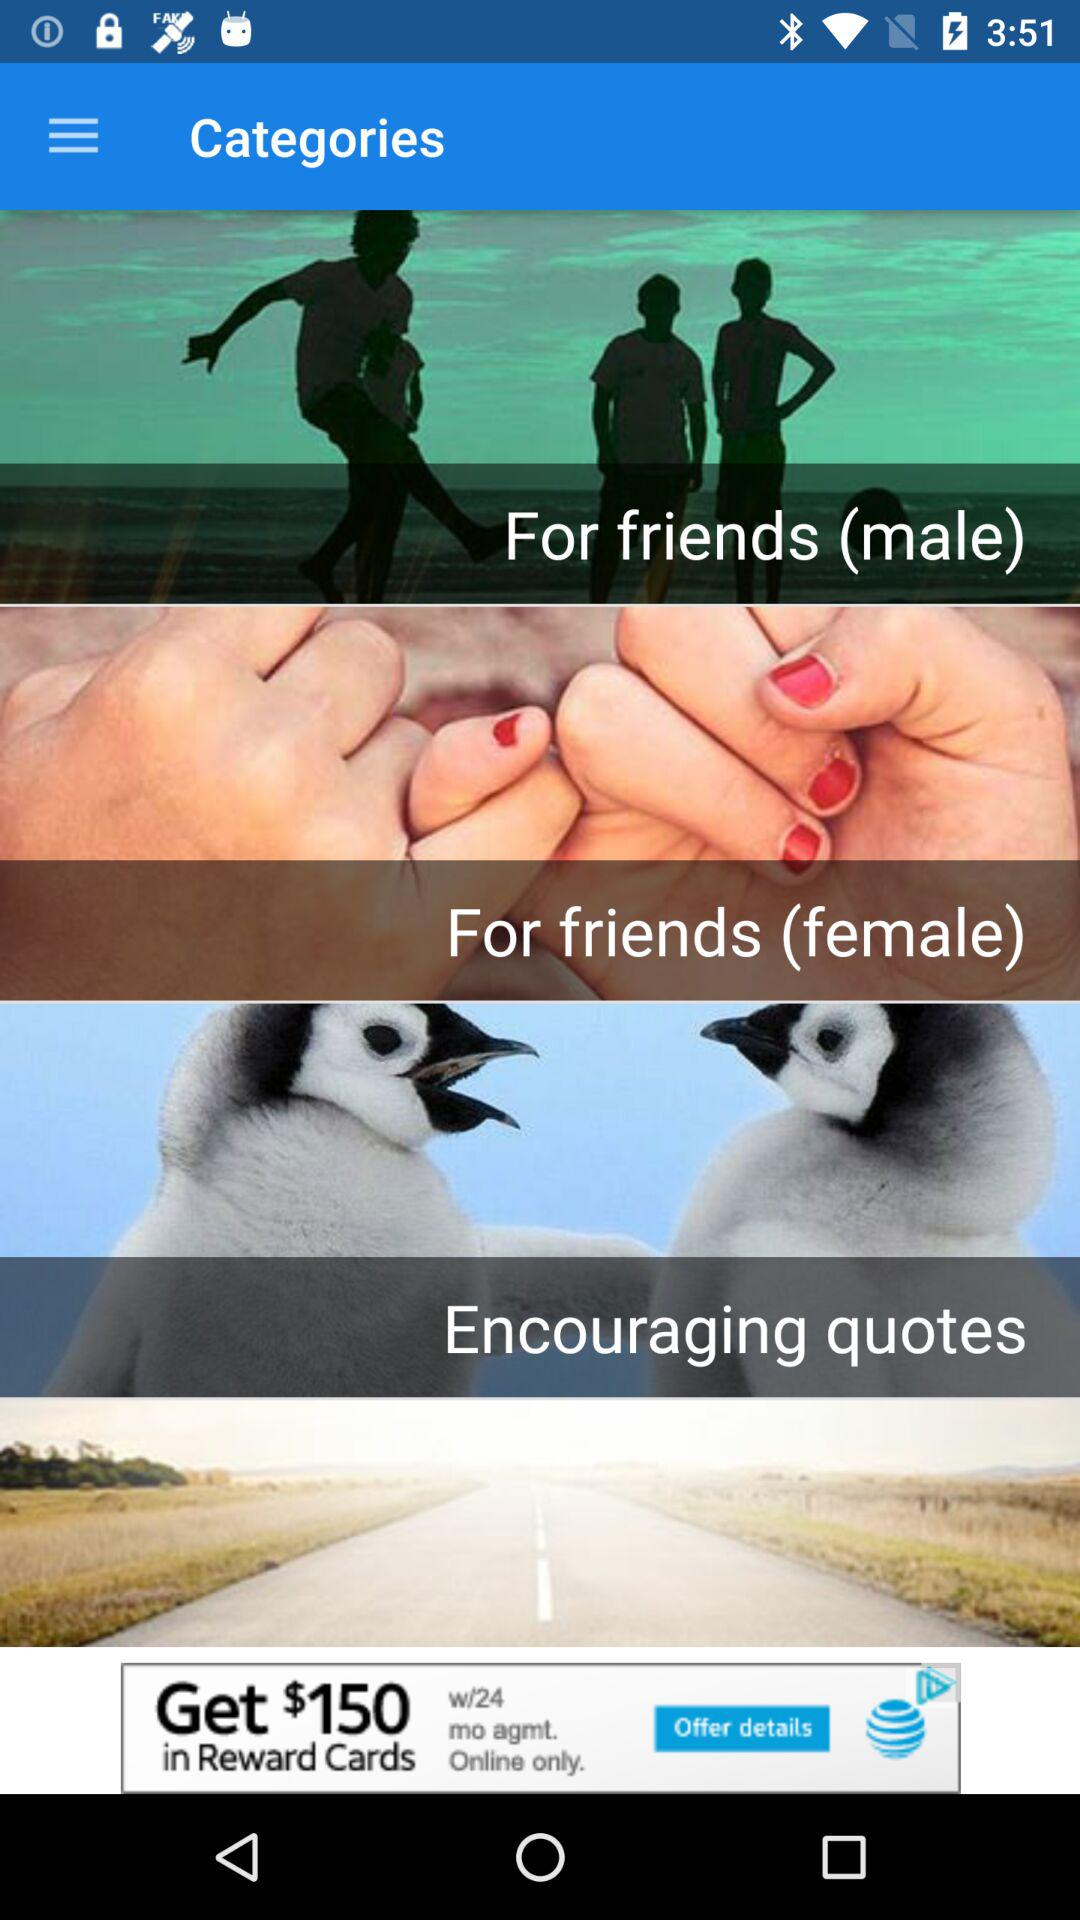What are the names of the different categories shown on the screen? The different categories are for friends (male), for friends (female) and encouraging quotes. 